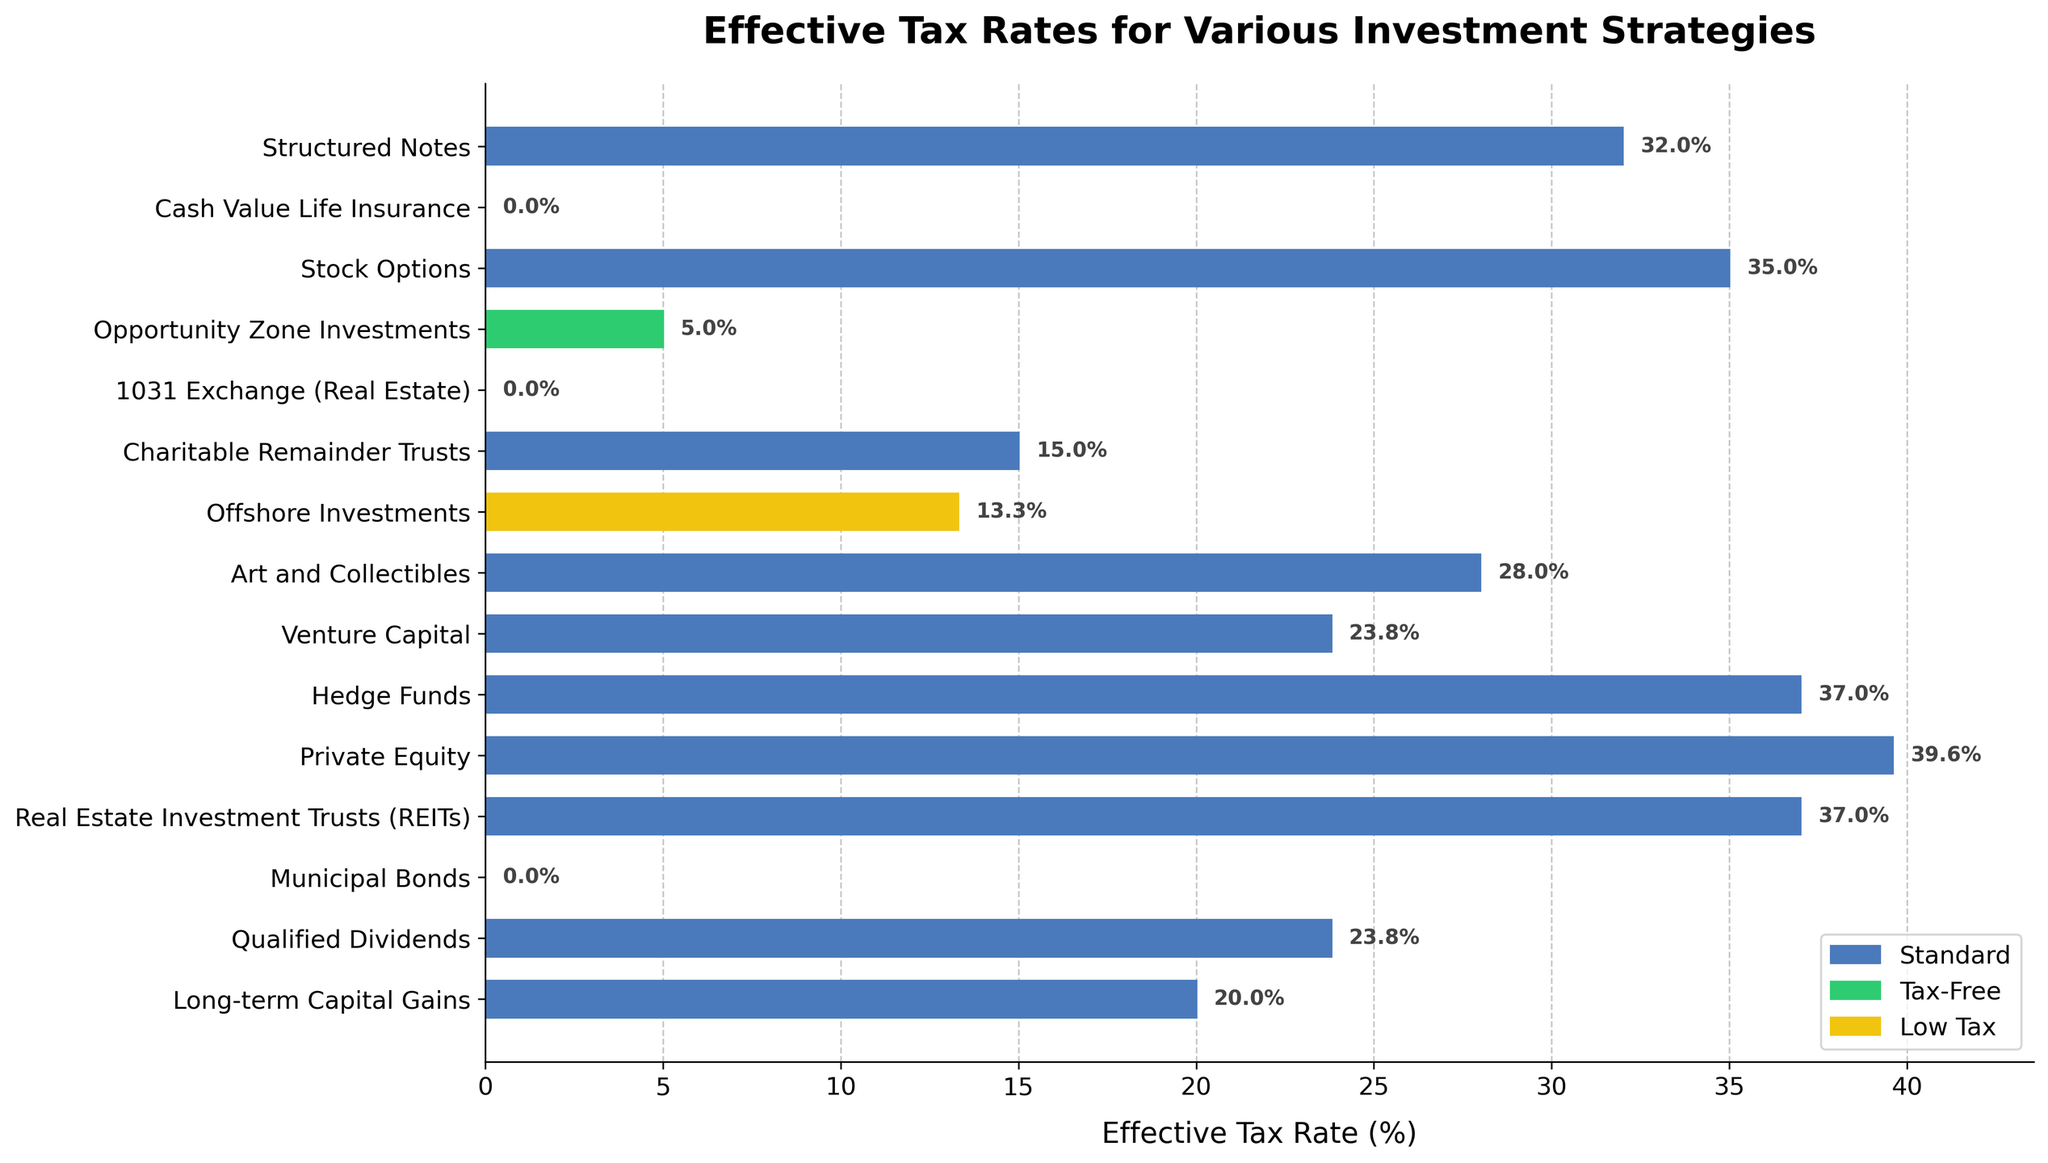What is the effective tax rate for municipal bonds? The figure shows a bar chart with the effective tax rate for various investment strategies. The bar representing "Municipal Bonds" is marked at 0%.
Answer: 0% Which investment strategy has the highest effective tax rate? By observing the height of the bars in the chart, the "Private Equity" investment strategy has the highest effective tax rate, marked at 39.6%.
Answer: Private Equity How many investment strategies have an effective tax rate of 0%? Looking at the bars marked in green (indicating tax-free strategies), there are three strategies with a 0% effective tax rate: "Municipal Bonds," "1031 Exchange (Real Estate)," and "Cash Value Life Insurance."
Answer: 3 What is the difference in effective tax rate between structured notes and opportunity zone investments? The effective tax rate for "Structured Notes" is shown as 32%, and for "Opportunity Zone Investments," it is 5%. The difference is calculated as 32% - 5% = 27%.
Answer: 27% Which investment strategy has a lower effective tax rate, venture capital or art and collectibles? By comparing the bars, "Venture Capital" has an effective tax rate of 23.8%, while "Art and Collectibles" is at 28%. Thus, "Venture Capital" has a lower rate than "Art and Collectibles."
Answer: Venture Capital What is the effective tax rate for the strategy colored in yellow? The strategy represented in yellow is "Offshore Investments," which has an effective tax rate of 13.3% as shown by the bar chart.
Answer: 13.3% Identify the three investment strategies with the lowest effective tax rates from the chart. By analyzing the bar lengths, the three investment strategies with the lowest effective tax rates are: "Municipal Bonds" (0%), "1031 Exchange (Real Estate)" (0%), and "Cash Value Life Insurance" (0%).
Answer: Municipal Bonds, 1031 Exchange (Real Estate), Cash Value Life Insurance What is the average effective tax rate for "Qualified Dividends," "Venture Capital," and "Art and Collectibles"? The effective tax rates are: "Qualified Dividends" (23.8%), "Venture Capital" (23.8%), and "Art and Collectibles" (28%). The average is calculated as (23.8% + 23.8% + 28%)/3 = 25.2%.
Answer: 25.2% Which strategies are associated with a color indicating tax-free investment in the chart? The bars colored in green indicate tax-free investments. The strategies associated are "Municipal Bonds," "1031 Exchange (Real Estate)," and "Cash Value Life Insurance."
Answer: Municipal Bonds, 1031 Exchange (Real Estate), Cash Value Life Insurance If an investor wants to minimize their tax rate, should they invest in hedge funds or offshore investments? Comparing the bars, "Hedge Funds" have an effective tax rate of 37%, while "Offshore Investments" have a tax rate of 13.3%. Therefore, offshore investments have a lower tax rate and would help minimize taxes.
Answer: Offshore Investments 